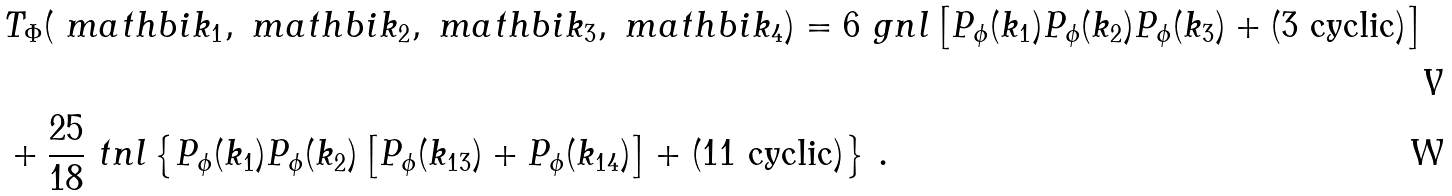Convert formula to latex. <formula><loc_0><loc_0><loc_500><loc_500>& T _ { \Phi } ( \ m a t h b i { k } _ { 1 } , \ m a t h b i { k } _ { 2 } , \ m a t h b i { k } _ { 3 } , \ m a t h b i { k } _ { 4 } ) = 6 \ g n l \left [ P _ { \phi } ( k _ { 1 } ) P _ { \phi } ( k _ { 2 } ) P _ { \phi } ( k _ { 3 } ) + \text {(3 cyclic)} \right ] \\ & + \frac { 2 5 } { 1 8 } \ t n l \left \{ P _ { \phi } ( k _ { 1 } ) P _ { \phi } ( k _ { 2 } ) \left [ P _ { \phi } ( k _ { 1 3 } ) + P _ { \phi } ( k _ { 1 4 } ) \right ] + \text {(11 cyclic)} \right \} \, .</formula> 